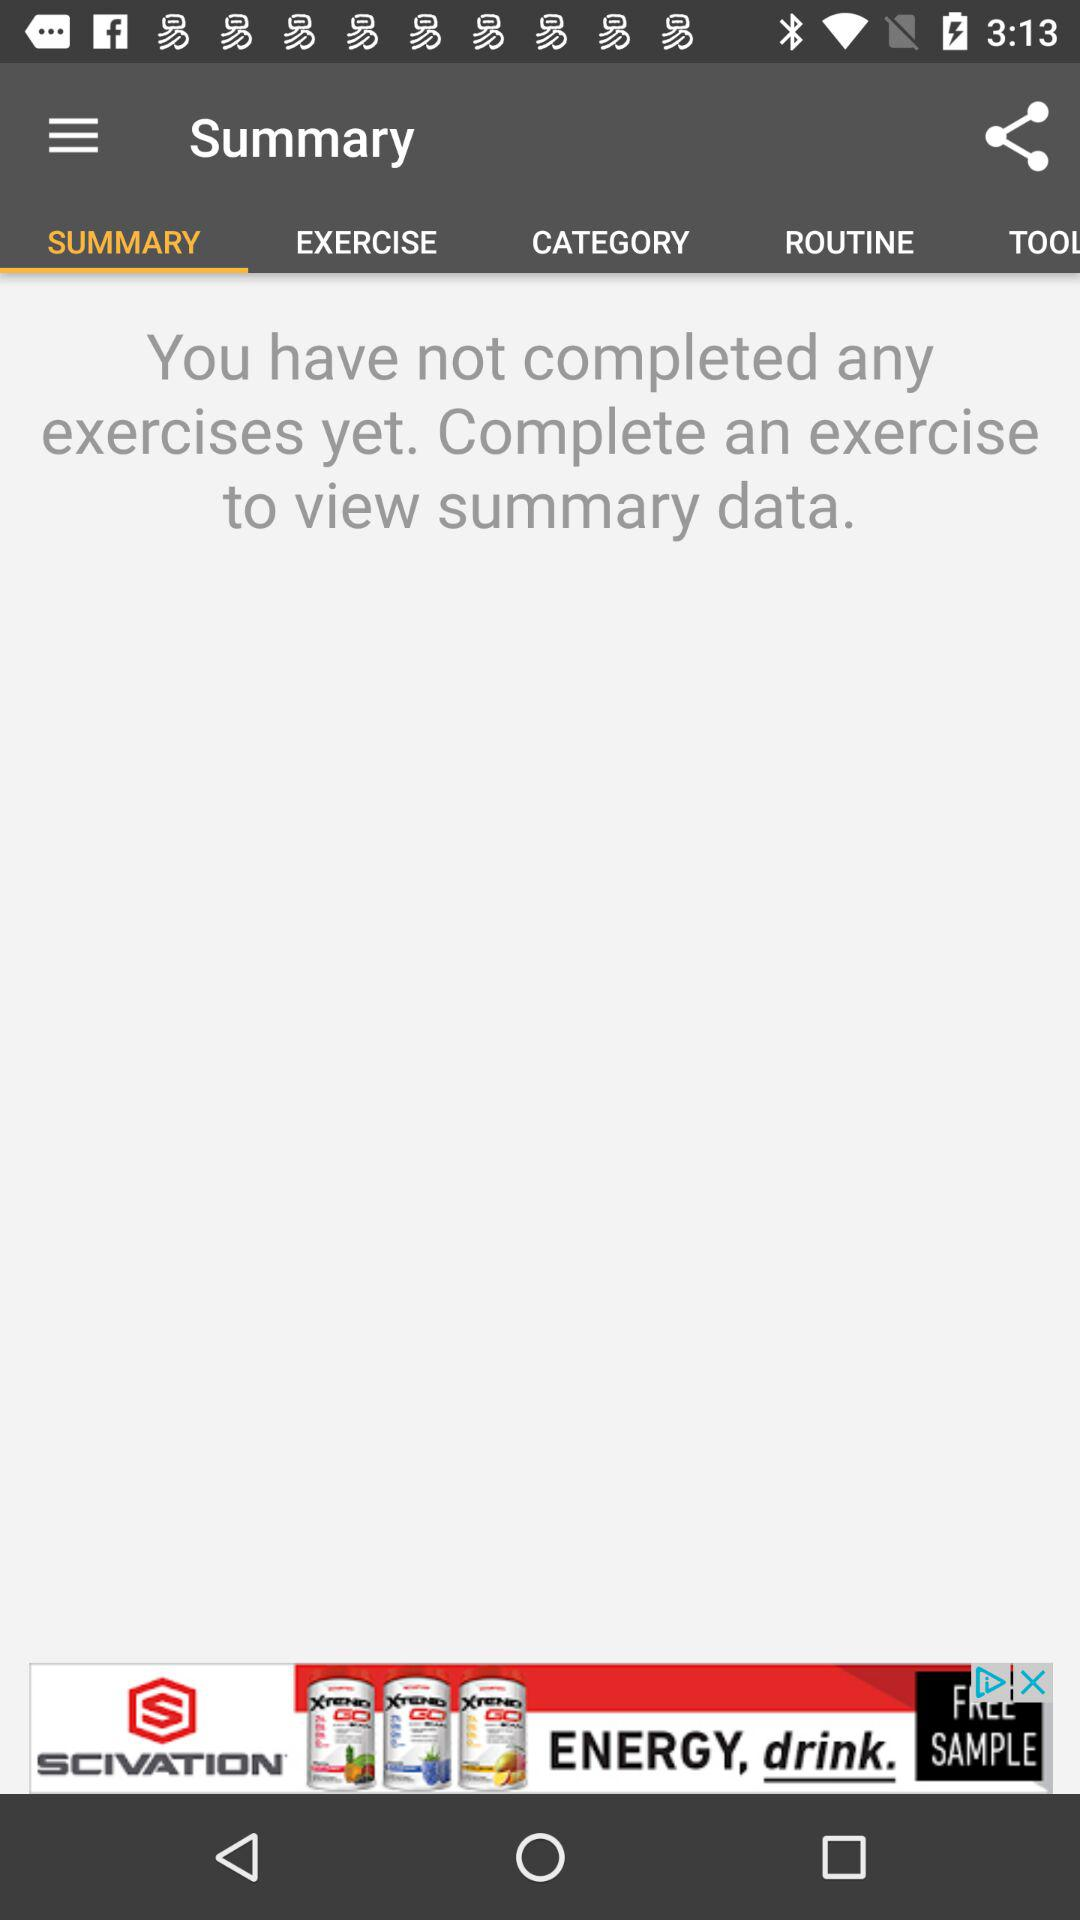How many exercises have been completed?
Answer the question using a single word or phrase. 0 